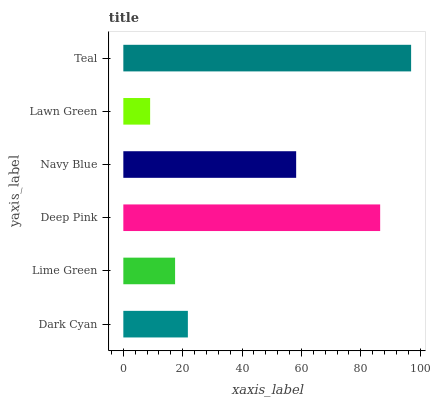Is Lawn Green the minimum?
Answer yes or no. Yes. Is Teal the maximum?
Answer yes or no. Yes. Is Lime Green the minimum?
Answer yes or no. No. Is Lime Green the maximum?
Answer yes or no. No. Is Dark Cyan greater than Lime Green?
Answer yes or no. Yes. Is Lime Green less than Dark Cyan?
Answer yes or no. Yes. Is Lime Green greater than Dark Cyan?
Answer yes or no. No. Is Dark Cyan less than Lime Green?
Answer yes or no. No. Is Navy Blue the high median?
Answer yes or no. Yes. Is Dark Cyan the low median?
Answer yes or no. Yes. Is Lime Green the high median?
Answer yes or no. No. Is Teal the low median?
Answer yes or no. No. 